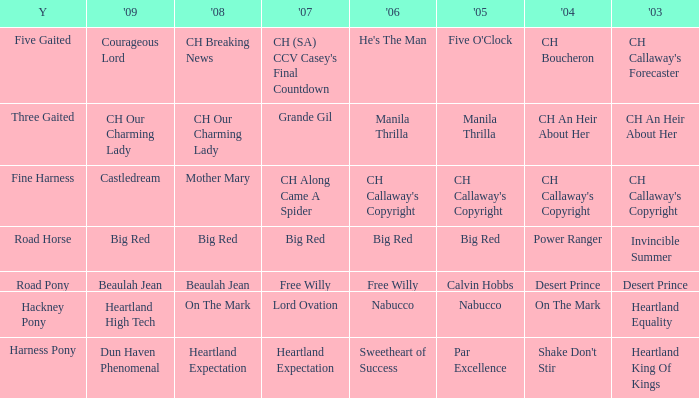What year is the 2007 big red? Road Horse. 